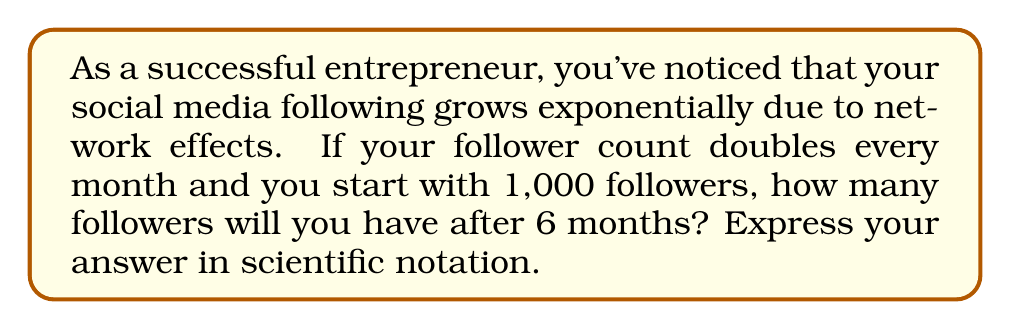Can you solve this math problem? Let's approach this step-by-step:

1) We start with 1,000 followers.

2) The follower count doubles every month, which means we're dealing with exponential growth.

3) The exponential function for this scenario is:

   $f(x) = 1000 * 2^x$

   Where $x$ is the number of months.

4) We want to know the follower count after 6 months, so we'll calculate $f(6)$:

   $f(6) = 1000 * 2^6$

5) Let's evaluate $2^6$:
   
   $2^6 = 2 * 2 * 2 * 2 * 2 * 2 = 64$

6) Now, we can multiply:

   $1000 * 64 = 64,000$

7) To express this in scientific notation, we move the decimal point 4 places to the left:

   $64,000 = 6.4 * 10^4$

Thus, after 6 months, you would have $6.4 * 10^4$ followers.
Answer: $6.4 * 10^4$ 